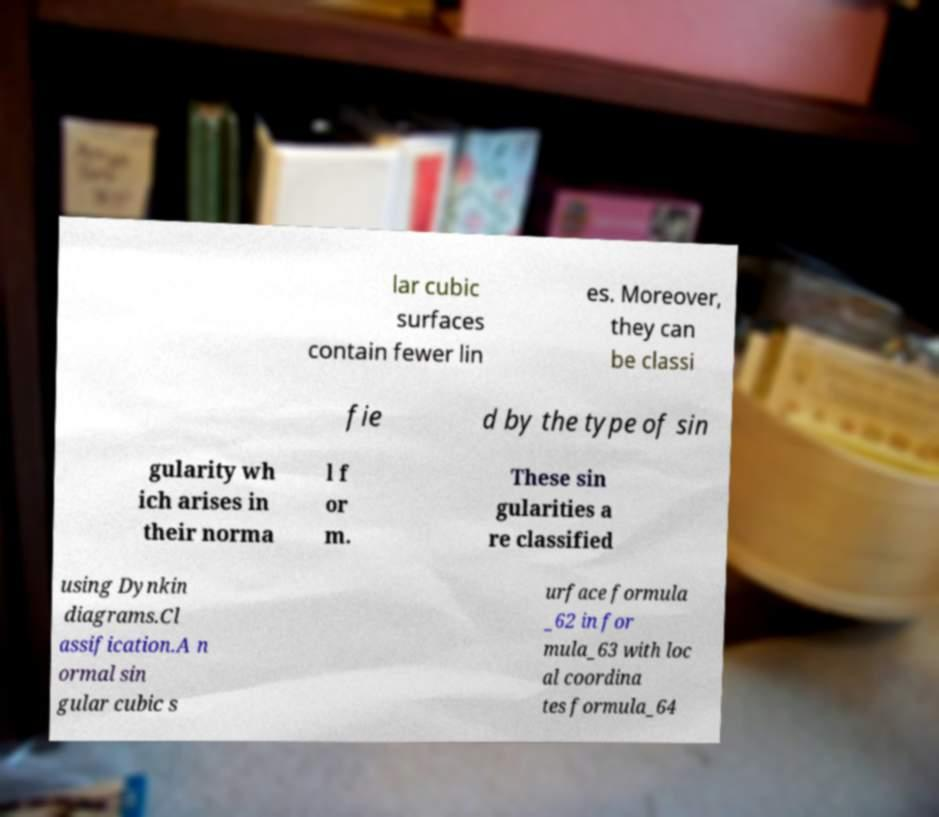Could you assist in decoding the text presented in this image and type it out clearly? lar cubic surfaces contain fewer lin es. Moreover, they can be classi fie d by the type of sin gularity wh ich arises in their norma l f or m. These sin gularities a re classified using Dynkin diagrams.Cl assification.A n ormal sin gular cubic s urface formula _62 in for mula_63 with loc al coordina tes formula_64 